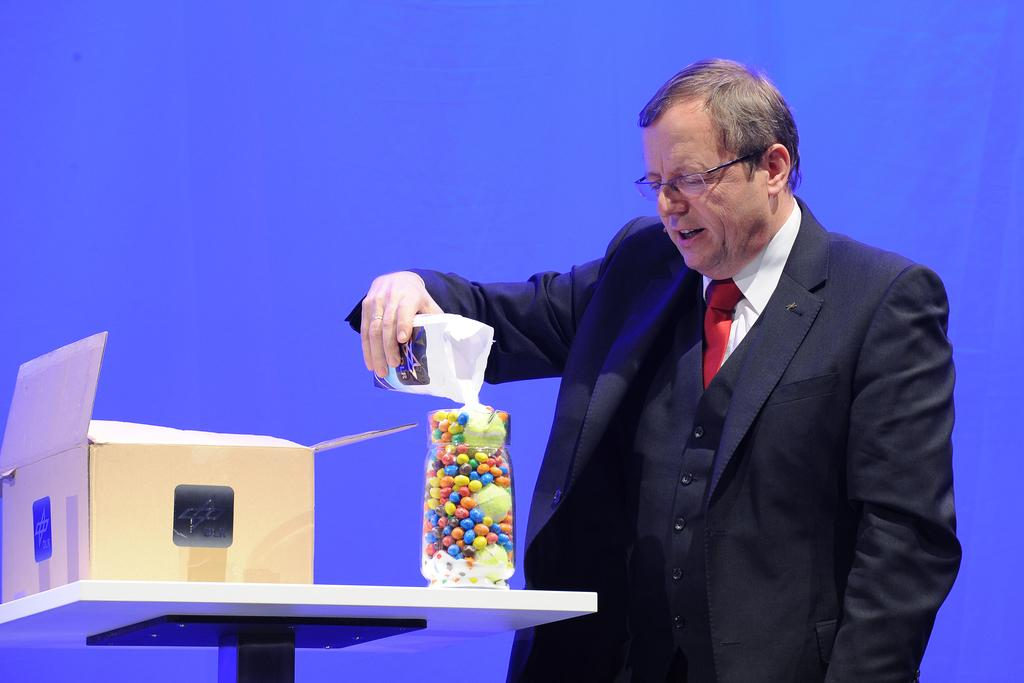What is present in the image? There is a person in the image. What is the person doing in the image? The person is holding an object. What else can be seen in the image? There are objects on a table in the image. What color is the background of the image? The background of the image is blue. How many spiders are crawling on the person's arm in the image? There are no spiders present in the image. What is the relationship between the person in the image and the person asking the question? The relationship between the person in the image and the person asking the question is not mentioned in the image or the provided facts. 